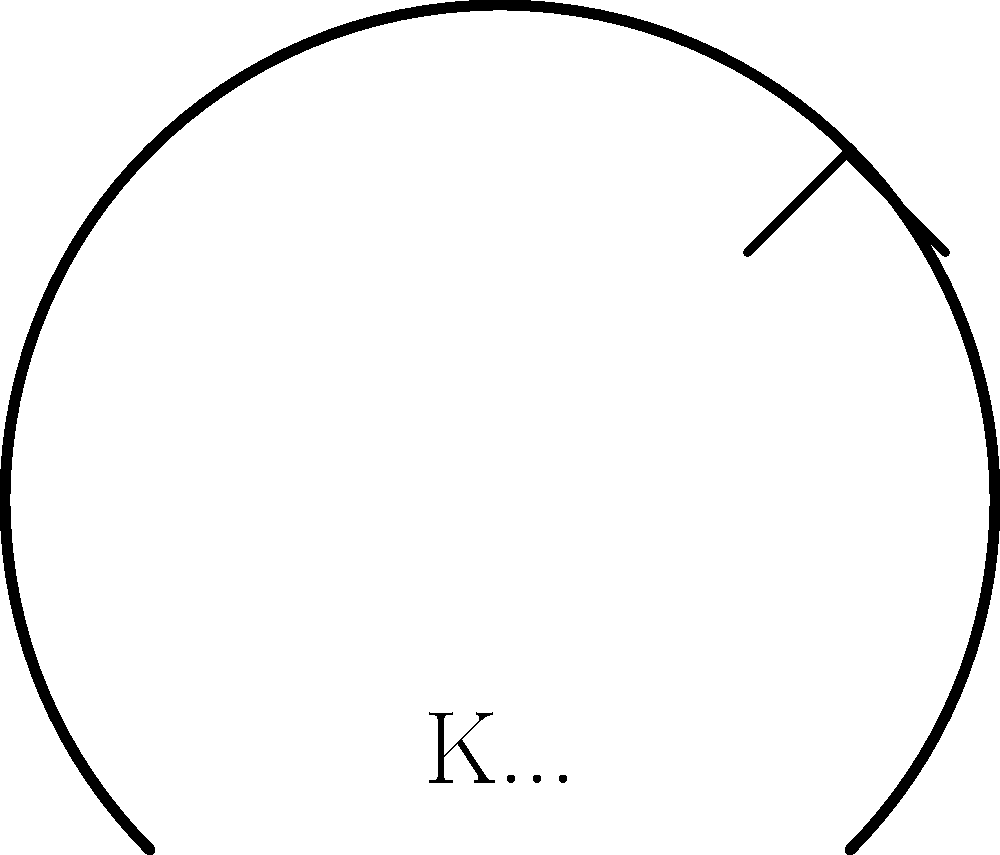Which local Kanchanaburi sports team's logo is partially shown in the image above? To identify the local Kanchanaburi sports team logo from this partial image, let's analyze the elements:

1. We see a partial circle, which is a common element in many sports logos.
2. There's a letter "K" visible at the bottom of the logo, suggesting the team name starts with K.
3. A partial star is visible in the upper right corner of the logo.
4. The question mentions it's a local Kanchanaburi team.

Given these clues, we can deduce that this is likely the logo of the Kanchanaburi FC, also known as the "Kanchanaburi Star." This football club is based in Kanchanaburi and competes in the Thai League 3 Western Region. Their logo features a circular design with the team name and a prominent star, which matches the partial elements we see in the image.
Answer: Kanchanaburi FC 